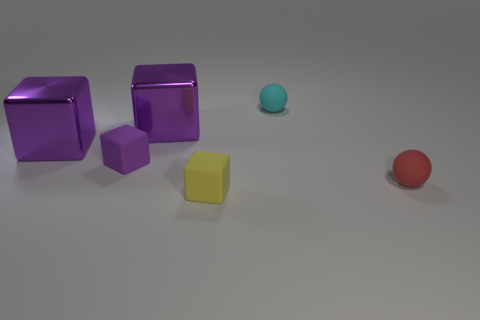What shape is the red thing that is made of the same material as the yellow block?
Make the answer very short. Sphere. Do the red object and the purple matte thing have the same size?
Your response must be concise. Yes. Do the sphere that is left of the red ball and the small yellow thing have the same material?
Your response must be concise. Yes. Is there any other thing that is made of the same material as the tiny cyan sphere?
Offer a very short reply. Yes. How many rubber balls are to the left of the big metal object that is on the left side of the tiny rubber cube that is behind the red object?
Provide a short and direct response. 0. There is a tiny cyan rubber object that is to the right of the small yellow object; is its shape the same as the small red matte object?
Offer a very short reply. Yes. What number of objects are big metallic things or matte balls that are to the left of the red ball?
Offer a very short reply. 3. Is the number of tiny blocks that are in front of the yellow rubber cube greater than the number of purple rubber things?
Keep it short and to the point. No. Are there an equal number of red objects behind the small purple matte object and small cyan balls in front of the yellow matte object?
Offer a terse response. Yes. Are there any tiny purple things in front of the small matte block that is on the left side of the tiny yellow rubber thing?
Give a very brief answer. No. 